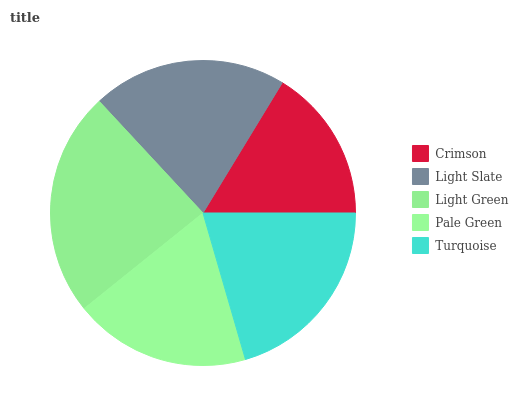Is Crimson the minimum?
Answer yes or no. Yes. Is Light Green the maximum?
Answer yes or no. Yes. Is Light Slate the minimum?
Answer yes or no. No. Is Light Slate the maximum?
Answer yes or no. No. Is Light Slate greater than Crimson?
Answer yes or no. Yes. Is Crimson less than Light Slate?
Answer yes or no. Yes. Is Crimson greater than Light Slate?
Answer yes or no. No. Is Light Slate less than Crimson?
Answer yes or no. No. Is Turquoise the high median?
Answer yes or no. Yes. Is Turquoise the low median?
Answer yes or no. Yes. Is Crimson the high median?
Answer yes or no. No. Is Pale Green the low median?
Answer yes or no. No. 